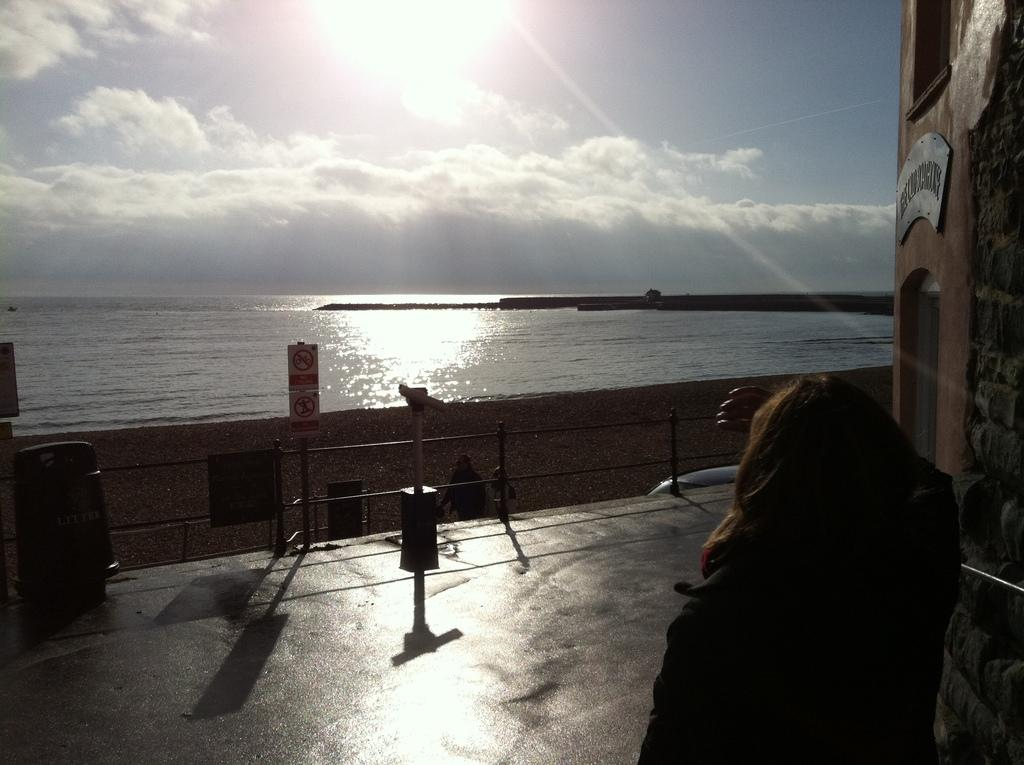What is the main subject in the foreground of the image? There is a woman standing in the foreground of the image. What is located beside the woman? There is a wall beside the woman. What type of environment is visible in front of the woman? There is a beach in front of the woman. How many bikes can be seen on the beach in the image? There are no bikes visible in the image; it only shows a woman standing beside a wall with a beach in front of her. 